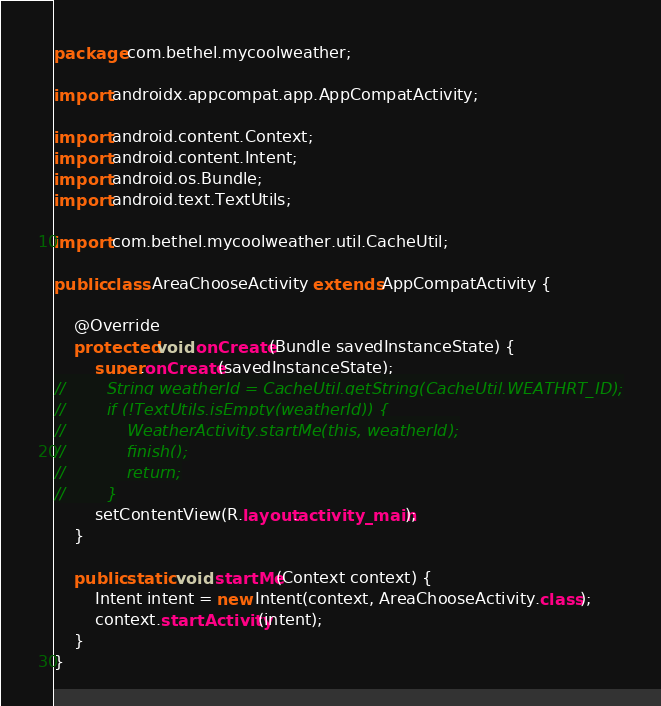Convert code to text. <code><loc_0><loc_0><loc_500><loc_500><_Java_>package com.bethel.mycoolweather;

import androidx.appcompat.app.AppCompatActivity;

import android.content.Context;
import android.content.Intent;
import android.os.Bundle;
import android.text.TextUtils;

import com.bethel.mycoolweather.util.CacheUtil;

public class AreaChooseActivity extends AppCompatActivity {

    @Override
    protected void onCreate(Bundle savedInstanceState) {
        super.onCreate(savedInstanceState);
//        String weatherId = CacheUtil.getString(CacheUtil.WEATHRT_ID);
//        if (!TextUtils.isEmpty(weatherId)) {
//            WeatherActivity.startMe(this, weatherId);
//            finish();
//            return;
//        }
        setContentView(R.layout.activity_main);
    }

    public static void startMe(Context context) {
        Intent intent = new Intent(context, AreaChooseActivity.class);
        context.startActivity(intent);
    }
}
</code> 